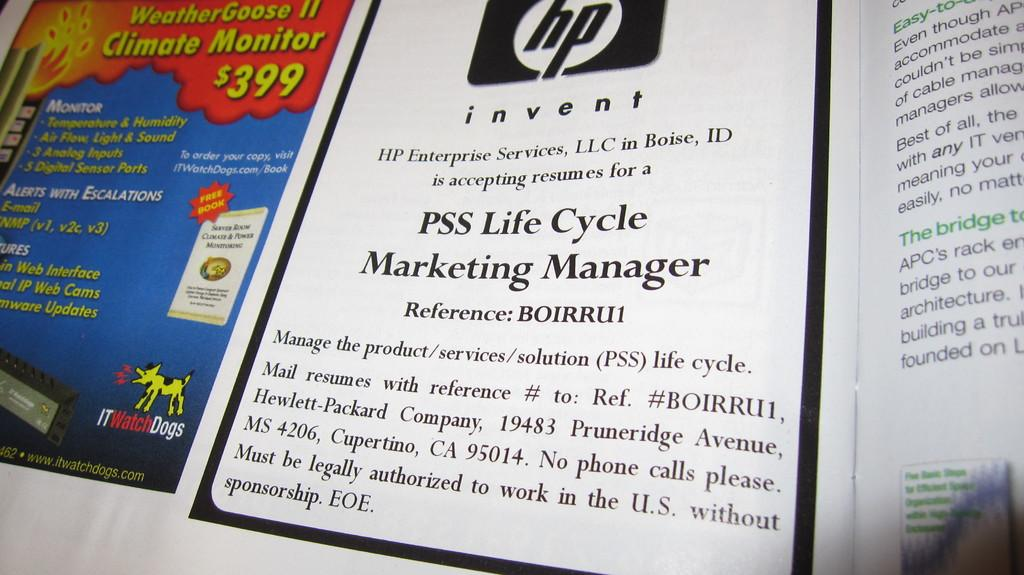<image>
Share a concise interpretation of the image provided. a page that has a title on it that says 'pss life cycle marketing manager' 